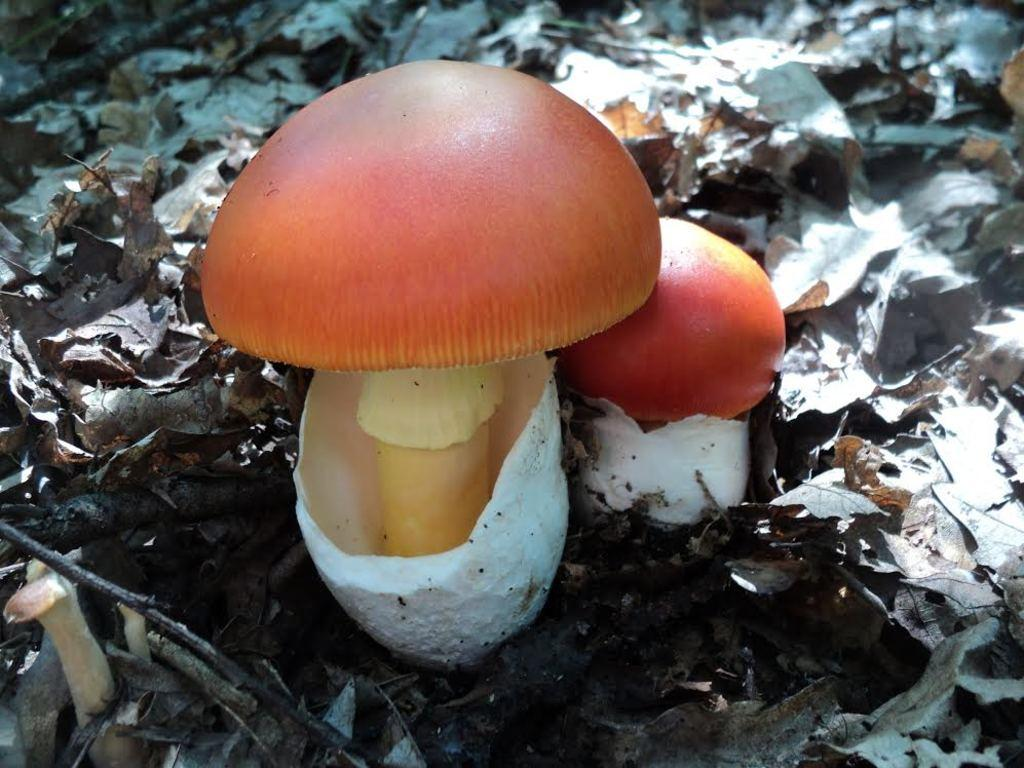What color is the mushroom in the image? The mushroom in the image is red. What object can be found on the ground in the image? There is a white shell on the ground in the image. What type of vegetation is present in the image? There are dried brown leaves in the image. What type of curtain can be seen hanging from the mushroom in the image? There is no curtain present in the image; it features a red mushroom, a white shell, and dried brown leaves. What sound does the alarm make in the image? There is no alarm present in the image. 